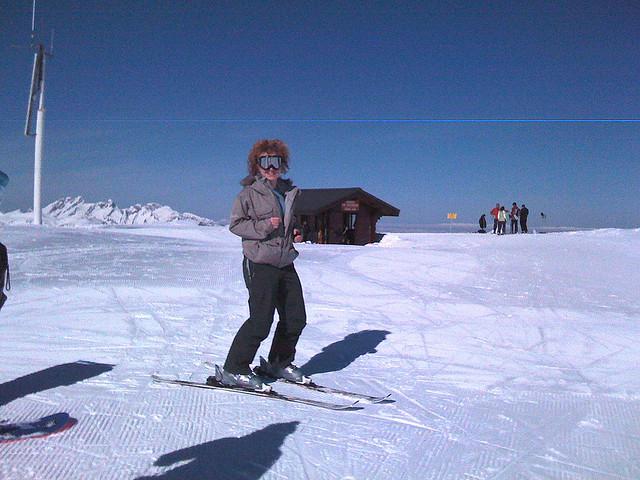How does the girl have her hair styled?
Answer briefly. Down and curly. What is on the person's face?
Concise answer only. Goggles. Are any pine trees pictured?
Answer briefly. No. Is there a storm coming?
Keep it brief. No. What color is this snowboarders pants?
Answer briefly. Black. Did she fall?
Answer briefly. No. Is this a black and white picture?
Give a very brief answer. No. Is this person dressed for the weather?
Concise answer only. Yes. Are his shades the same color as his shirt?
Short answer required. No. Is the girl resting?
Be succinct. No. Why is she wearing goggles?
Keep it brief. To protect her eyes. Is this taking place in the summer?
Write a very short answer. No. Is evening?
Be succinct. No. What is he doing?
Give a very brief answer. Skiing. What kind of sport is this?
Answer briefly. Skiing. How many people in the shot?
Keep it brief. 6. Is this person riding?
Answer briefly. Skis. Is the person wet?
Short answer required. No. 